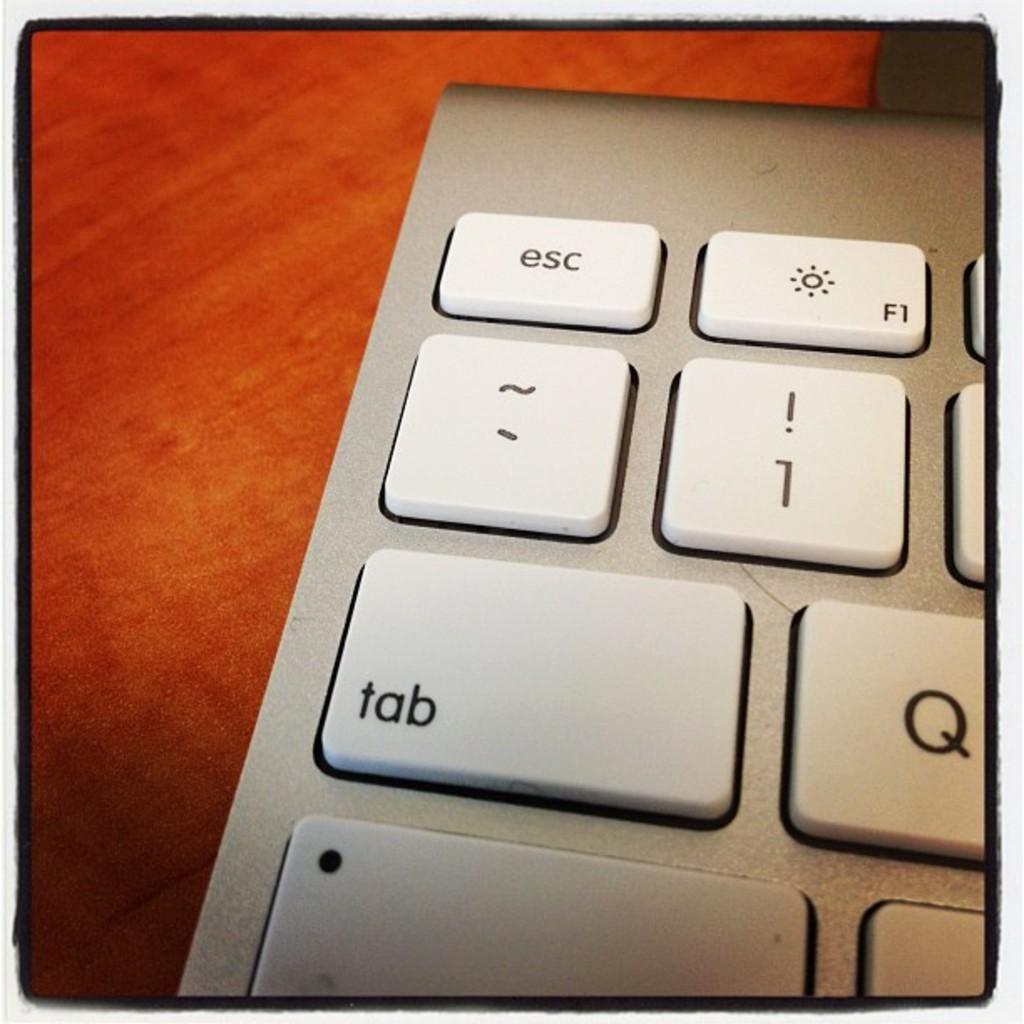What can i do with the first key on this keyboard?
Provide a short and direct response. Esc. What does the top left key say?
Offer a very short reply. Esc. 